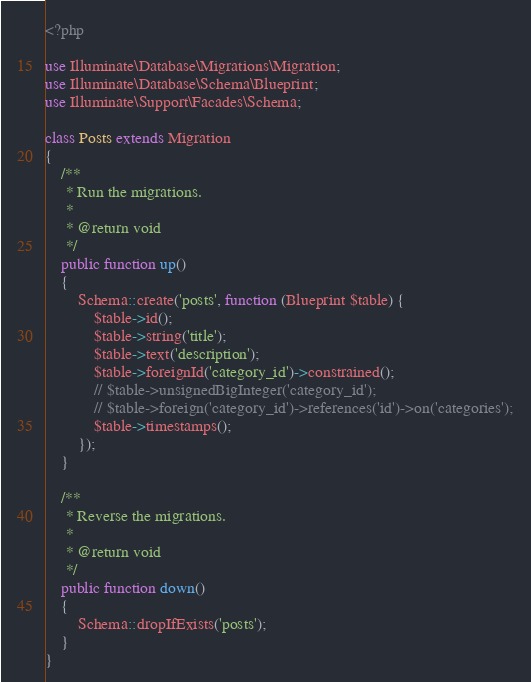<code> <loc_0><loc_0><loc_500><loc_500><_PHP_><?php

use Illuminate\Database\Migrations\Migration;
use Illuminate\Database\Schema\Blueprint;
use Illuminate\Support\Facades\Schema;

class Posts extends Migration
{
    /**
     * Run the migrations.
     *
     * @return void
     */
    public function up()
    {
        Schema::create('posts', function (Blueprint $table) {
            $table->id();
            $table->string('title');
            $table->text('description');
            $table->foreignId('category_id')->constrained();
            // $table->unsignedBigInteger('category_id');
            // $table->foreign('category_id')->references('id')->on('categories');
            $table->timestamps();
        });
    }

    /**
     * Reverse the migrations.
     *
     * @return void
     */
    public function down()
    {
        Schema::dropIfExists('posts');
    }
}
</code> 